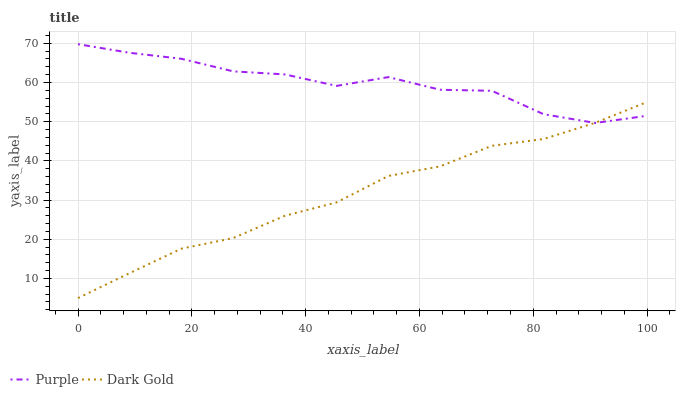Does Dark Gold have the maximum area under the curve?
Answer yes or no. No. Is Dark Gold the roughest?
Answer yes or no. No. Does Dark Gold have the highest value?
Answer yes or no. No. 